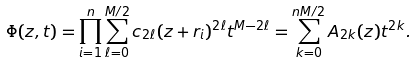<formula> <loc_0><loc_0><loc_500><loc_500>\Phi ( z , t ) = \prod _ { i = 1 } ^ { n } \sum _ { \ell = 0 } ^ { M / 2 } c _ { 2 \ell } ( z + r _ { i } ) ^ { 2 \ell } t ^ { M - 2 \ell } = \sum _ { k = 0 } ^ { n M / 2 } A _ { 2 k } ( z ) t ^ { 2 k } .</formula> 